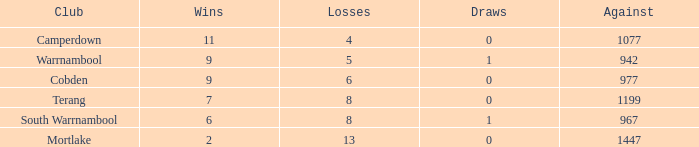When there are more than 8 losses and less than 2 wins, what is the draw count? None. 